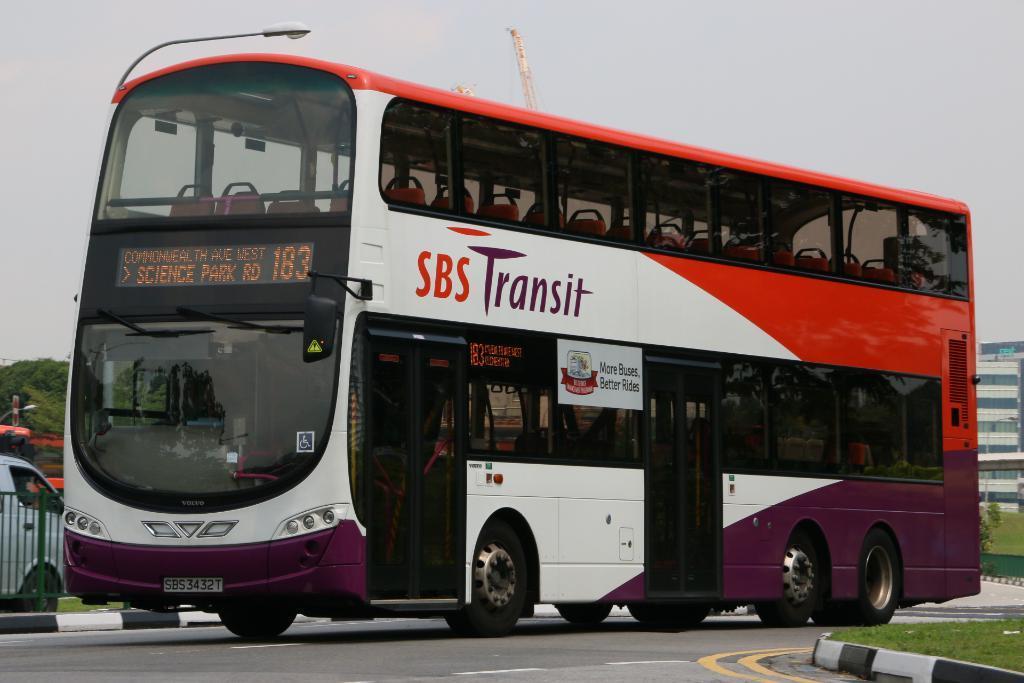How would you summarize this image in a sentence or two? In this image I can see few vehicles,fencing,green grass,light poles,building and trees. The sky is in white color. 